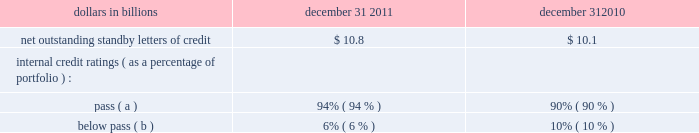Whether or not any claims asserted against us or others to whom we may have indemnification obligations , whether in the proceedings or other matters described above or otherwise , will have a material adverse effect on our results of operations in any future reporting period , which will depend on , among other things , the amount of the loss resulting from the claim and the amount of income otherwise reported for the reporting period .
See note 23 commitments and guarantees for additional information regarding the visa indemnification and our other obligations to provide indemnification , including to current and former officers , directors , employees and agents of pnc and companies we have acquired , including national city .
Note 23 commitments and guarantees equity funding and other commitments our unfunded commitments at december 31 , 2011 included private equity investments of $ 247 million , and other investments of $ 3 million .
Standby letters of credit we issue standby letters of credit and have risk participations in standby letters of credit and bankers 2019 acceptances issued by other financial institutions , in each case to support obligations of our customers to third parties , such as remarketing programs for customers 2019 variable rate demand notes .
Net outstanding standby letters of credit and internal credit ratings were as follows : net outstanding standby letters of credit dollars in billions december 31 december 31 .
( a ) indicates that expected risk of loss is currently low .
( b ) indicates a higher degree of risk of default .
If the customer fails to meet its financial or performance obligation to the third party under the terms of the contract or there is a need to support a remarketing program , then upon the request of the guaranteed party , we would be obligated to make payment to them .
The standby letters of credit and risk participations in standby letters of credit and bankers 2019 acceptances outstanding on december 31 , 2011 had terms ranging from less than 1 year to 7 years .
The aggregate maximum amount of future payments pnc could be required to make under outstanding standby letters of credit and risk participations in standby letters of credit and bankers 2019 acceptances was $ 14.4 billion at december 31 , 2011 , of which $ 7.4 billion support remarketing programs .
As of december 31 , 2011 , assets of $ 2.0 billion secured certain specifically identified standby letters of credit .
Recourse provisions from third parties of $ 3.6 billion were also available for this purpose as of december 31 , 2011 .
In addition , a portion of the remaining standby letters of credit and letter of credit risk participations issued on behalf of specific customers is also secured by collateral or guarantees that secure the customers 2019 other obligations to us .
The carrying amount of the liability for our obligations related to standby letters of credit and risk participations in standby letters of credit and bankers 2019 acceptances was $ 247 million at december 31 , 2011 .
Standby bond purchase agreements and other liquidity facilities we enter into standby bond purchase agreements to support municipal bond obligations .
At december 31 , 2011 , the aggregate of our commitments under these facilities was $ 543 million .
We also enter into certain other liquidity facilities to support individual pools of receivables acquired by commercial paper conduits .
At december 31 , 2011 , our total commitments under these facilities were $ 199 million .
Indemnifications we are a party to numerous acquisition or divestiture agreements under which we have purchased or sold , or agreed to purchase or sell , various types of assets .
These agreements can cover the purchase or sale of : 2022 entire businesses , 2022 loan portfolios , 2022 branch banks , 2022 partial interests in companies , or 2022 other types of assets .
These agreements generally include indemnification provisions under which we indemnify the third parties to these agreements against a variety of risks to the indemnified parties as a result of the transaction in question .
When pnc is the seller , the indemnification provisions will generally also provide the buyer with protection relating to the quality of the assets we are selling and the extent of any liabilities being assumed by the buyer .
Due to the nature of these indemnification provisions , we cannot quantify the total potential exposure to us resulting from them .
We provide indemnification in connection with securities offering transactions in which we are involved .
When we are the issuer of the securities , we provide indemnification to the underwriters or placement agents analogous to the indemnification provided to the purchasers of businesses from us , as described above .
When we are an underwriter or placement agent , we provide a limited indemnification to the issuer related to our actions in connection with the offering and , if there are other underwriters , indemnification to the other underwriters intended to result in an appropriate sharing of the risk of participating in the offering .
Due to the nature of these indemnification provisions , we cannot quantify the total potential exposure to us resulting from them .
In the ordinary course of business , we enter into certain types of agreements that include provisions for indemnifying third the pnc financial services group , inc .
2013 form 10-k 197 .
What is the total unfunded commitments at december 31 , 2011 including private equity investments and other investments , in millions? 
Computations: (247 + 3)
Answer: 250.0. 